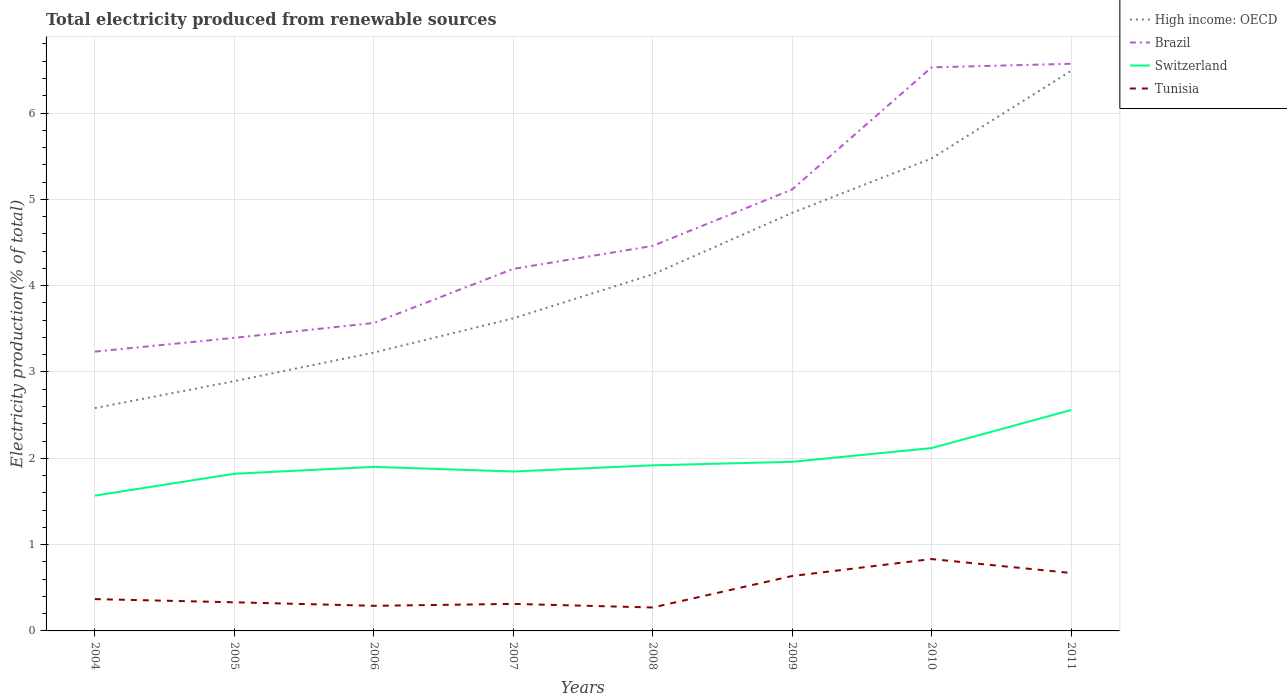How many different coloured lines are there?
Provide a short and direct response. 4. Does the line corresponding to Brazil intersect with the line corresponding to Switzerland?
Offer a very short reply. No. Is the number of lines equal to the number of legend labels?
Provide a succinct answer. Yes. Across all years, what is the maximum total electricity produced in Brazil?
Make the answer very short. 3.24. What is the total total electricity produced in Switzerland in the graph?
Your response must be concise. -0.99. What is the difference between the highest and the second highest total electricity produced in Brazil?
Offer a terse response. 3.33. Is the total electricity produced in High income: OECD strictly greater than the total electricity produced in Brazil over the years?
Provide a short and direct response. Yes. How many lines are there?
Give a very brief answer. 4. How many years are there in the graph?
Provide a short and direct response. 8. What is the difference between two consecutive major ticks on the Y-axis?
Your answer should be compact. 1. Are the values on the major ticks of Y-axis written in scientific E-notation?
Provide a short and direct response. No. Does the graph contain any zero values?
Offer a terse response. No. Does the graph contain grids?
Make the answer very short. Yes. What is the title of the graph?
Your answer should be very brief. Total electricity produced from renewable sources. What is the label or title of the X-axis?
Keep it short and to the point. Years. What is the Electricity production(% of total) in High income: OECD in 2004?
Keep it short and to the point. 2.58. What is the Electricity production(% of total) in Brazil in 2004?
Provide a short and direct response. 3.24. What is the Electricity production(% of total) in Switzerland in 2004?
Your response must be concise. 1.57. What is the Electricity production(% of total) in Tunisia in 2004?
Give a very brief answer. 0.37. What is the Electricity production(% of total) in High income: OECD in 2005?
Your answer should be compact. 2.89. What is the Electricity production(% of total) in Brazil in 2005?
Your response must be concise. 3.4. What is the Electricity production(% of total) in Switzerland in 2005?
Your response must be concise. 1.82. What is the Electricity production(% of total) of Tunisia in 2005?
Offer a terse response. 0.33. What is the Electricity production(% of total) in High income: OECD in 2006?
Your answer should be compact. 3.22. What is the Electricity production(% of total) of Brazil in 2006?
Give a very brief answer. 3.57. What is the Electricity production(% of total) of Switzerland in 2006?
Provide a short and direct response. 1.9. What is the Electricity production(% of total) in Tunisia in 2006?
Your answer should be compact. 0.29. What is the Electricity production(% of total) of High income: OECD in 2007?
Your response must be concise. 3.62. What is the Electricity production(% of total) of Brazil in 2007?
Offer a very short reply. 4.19. What is the Electricity production(% of total) of Switzerland in 2007?
Give a very brief answer. 1.85. What is the Electricity production(% of total) of Tunisia in 2007?
Make the answer very short. 0.31. What is the Electricity production(% of total) in High income: OECD in 2008?
Give a very brief answer. 4.13. What is the Electricity production(% of total) in Brazil in 2008?
Provide a succinct answer. 4.46. What is the Electricity production(% of total) of Switzerland in 2008?
Your response must be concise. 1.92. What is the Electricity production(% of total) of Tunisia in 2008?
Make the answer very short. 0.27. What is the Electricity production(% of total) in High income: OECD in 2009?
Your answer should be compact. 4.84. What is the Electricity production(% of total) of Brazil in 2009?
Your response must be concise. 5.11. What is the Electricity production(% of total) of Switzerland in 2009?
Make the answer very short. 1.96. What is the Electricity production(% of total) of Tunisia in 2009?
Provide a short and direct response. 0.64. What is the Electricity production(% of total) in High income: OECD in 2010?
Make the answer very short. 5.47. What is the Electricity production(% of total) in Brazil in 2010?
Make the answer very short. 6.53. What is the Electricity production(% of total) of Switzerland in 2010?
Offer a terse response. 2.12. What is the Electricity production(% of total) in Tunisia in 2010?
Ensure brevity in your answer.  0.83. What is the Electricity production(% of total) of High income: OECD in 2011?
Ensure brevity in your answer.  6.49. What is the Electricity production(% of total) of Brazil in 2011?
Provide a short and direct response. 6.57. What is the Electricity production(% of total) of Switzerland in 2011?
Give a very brief answer. 2.56. What is the Electricity production(% of total) of Tunisia in 2011?
Ensure brevity in your answer.  0.67. Across all years, what is the maximum Electricity production(% of total) in High income: OECD?
Offer a very short reply. 6.49. Across all years, what is the maximum Electricity production(% of total) in Brazil?
Provide a succinct answer. 6.57. Across all years, what is the maximum Electricity production(% of total) in Switzerland?
Make the answer very short. 2.56. Across all years, what is the maximum Electricity production(% of total) of Tunisia?
Your response must be concise. 0.83. Across all years, what is the minimum Electricity production(% of total) in High income: OECD?
Provide a succinct answer. 2.58. Across all years, what is the minimum Electricity production(% of total) in Brazil?
Ensure brevity in your answer.  3.24. Across all years, what is the minimum Electricity production(% of total) in Switzerland?
Your response must be concise. 1.57. Across all years, what is the minimum Electricity production(% of total) in Tunisia?
Provide a short and direct response. 0.27. What is the total Electricity production(% of total) in High income: OECD in the graph?
Ensure brevity in your answer.  33.26. What is the total Electricity production(% of total) in Brazil in the graph?
Your answer should be compact. 37.07. What is the total Electricity production(% of total) in Switzerland in the graph?
Keep it short and to the point. 15.69. What is the total Electricity production(% of total) in Tunisia in the graph?
Offer a terse response. 3.72. What is the difference between the Electricity production(% of total) in High income: OECD in 2004 and that in 2005?
Offer a very short reply. -0.31. What is the difference between the Electricity production(% of total) of Brazil in 2004 and that in 2005?
Provide a short and direct response. -0.16. What is the difference between the Electricity production(% of total) in Switzerland in 2004 and that in 2005?
Provide a succinct answer. -0.25. What is the difference between the Electricity production(% of total) in Tunisia in 2004 and that in 2005?
Offer a very short reply. 0.04. What is the difference between the Electricity production(% of total) in High income: OECD in 2004 and that in 2006?
Make the answer very short. -0.64. What is the difference between the Electricity production(% of total) in Brazil in 2004 and that in 2006?
Give a very brief answer. -0.33. What is the difference between the Electricity production(% of total) of Switzerland in 2004 and that in 2006?
Make the answer very short. -0.33. What is the difference between the Electricity production(% of total) in Tunisia in 2004 and that in 2006?
Your response must be concise. 0.08. What is the difference between the Electricity production(% of total) in High income: OECD in 2004 and that in 2007?
Make the answer very short. -1.04. What is the difference between the Electricity production(% of total) in Brazil in 2004 and that in 2007?
Offer a very short reply. -0.96. What is the difference between the Electricity production(% of total) of Switzerland in 2004 and that in 2007?
Offer a terse response. -0.28. What is the difference between the Electricity production(% of total) of Tunisia in 2004 and that in 2007?
Your response must be concise. 0.06. What is the difference between the Electricity production(% of total) in High income: OECD in 2004 and that in 2008?
Make the answer very short. -1.55. What is the difference between the Electricity production(% of total) of Brazil in 2004 and that in 2008?
Ensure brevity in your answer.  -1.22. What is the difference between the Electricity production(% of total) in Switzerland in 2004 and that in 2008?
Offer a very short reply. -0.35. What is the difference between the Electricity production(% of total) in Tunisia in 2004 and that in 2008?
Your response must be concise. 0.1. What is the difference between the Electricity production(% of total) of High income: OECD in 2004 and that in 2009?
Offer a terse response. -2.26. What is the difference between the Electricity production(% of total) in Brazil in 2004 and that in 2009?
Offer a terse response. -1.88. What is the difference between the Electricity production(% of total) in Switzerland in 2004 and that in 2009?
Give a very brief answer. -0.39. What is the difference between the Electricity production(% of total) of Tunisia in 2004 and that in 2009?
Ensure brevity in your answer.  -0.27. What is the difference between the Electricity production(% of total) of High income: OECD in 2004 and that in 2010?
Keep it short and to the point. -2.89. What is the difference between the Electricity production(% of total) of Brazil in 2004 and that in 2010?
Offer a very short reply. -3.29. What is the difference between the Electricity production(% of total) in Switzerland in 2004 and that in 2010?
Give a very brief answer. -0.55. What is the difference between the Electricity production(% of total) of Tunisia in 2004 and that in 2010?
Your answer should be very brief. -0.46. What is the difference between the Electricity production(% of total) in High income: OECD in 2004 and that in 2011?
Your response must be concise. -3.91. What is the difference between the Electricity production(% of total) of Brazil in 2004 and that in 2011?
Make the answer very short. -3.33. What is the difference between the Electricity production(% of total) in Switzerland in 2004 and that in 2011?
Offer a very short reply. -0.99. What is the difference between the Electricity production(% of total) of Tunisia in 2004 and that in 2011?
Give a very brief answer. -0.3. What is the difference between the Electricity production(% of total) of High income: OECD in 2005 and that in 2006?
Make the answer very short. -0.33. What is the difference between the Electricity production(% of total) of Brazil in 2005 and that in 2006?
Your response must be concise. -0.17. What is the difference between the Electricity production(% of total) of Switzerland in 2005 and that in 2006?
Ensure brevity in your answer.  -0.08. What is the difference between the Electricity production(% of total) in Tunisia in 2005 and that in 2006?
Provide a short and direct response. 0.04. What is the difference between the Electricity production(% of total) in High income: OECD in 2005 and that in 2007?
Provide a short and direct response. -0.73. What is the difference between the Electricity production(% of total) in Brazil in 2005 and that in 2007?
Provide a succinct answer. -0.8. What is the difference between the Electricity production(% of total) in Switzerland in 2005 and that in 2007?
Ensure brevity in your answer.  -0.03. What is the difference between the Electricity production(% of total) of Tunisia in 2005 and that in 2007?
Give a very brief answer. 0.02. What is the difference between the Electricity production(% of total) in High income: OECD in 2005 and that in 2008?
Offer a terse response. -1.24. What is the difference between the Electricity production(% of total) in Brazil in 2005 and that in 2008?
Your answer should be compact. -1.06. What is the difference between the Electricity production(% of total) of Switzerland in 2005 and that in 2008?
Provide a short and direct response. -0.1. What is the difference between the Electricity production(% of total) in Tunisia in 2005 and that in 2008?
Keep it short and to the point. 0.06. What is the difference between the Electricity production(% of total) of High income: OECD in 2005 and that in 2009?
Provide a short and direct response. -1.95. What is the difference between the Electricity production(% of total) of Brazil in 2005 and that in 2009?
Make the answer very short. -1.72. What is the difference between the Electricity production(% of total) of Switzerland in 2005 and that in 2009?
Provide a short and direct response. -0.14. What is the difference between the Electricity production(% of total) of Tunisia in 2005 and that in 2009?
Your response must be concise. -0.3. What is the difference between the Electricity production(% of total) of High income: OECD in 2005 and that in 2010?
Provide a short and direct response. -2.58. What is the difference between the Electricity production(% of total) in Brazil in 2005 and that in 2010?
Ensure brevity in your answer.  -3.13. What is the difference between the Electricity production(% of total) in Switzerland in 2005 and that in 2010?
Offer a very short reply. -0.3. What is the difference between the Electricity production(% of total) in Tunisia in 2005 and that in 2010?
Your answer should be compact. -0.5. What is the difference between the Electricity production(% of total) of High income: OECD in 2005 and that in 2011?
Make the answer very short. -3.6. What is the difference between the Electricity production(% of total) of Brazil in 2005 and that in 2011?
Your answer should be compact. -3.18. What is the difference between the Electricity production(% of total) in Switzerland in 2005 and that in 2011?
Offer a very short reply. -0.74. What is the difference between the Electricity production(% of total) of Tunisia in 2005 and that in 2011?
Provide a short and direct response. -0.34. What is the difference between the Electricity production(% of total) of High income: OECD in 2006 and that in 2007?
Give a very brief answer. -0.4. What is the difference between the Electricity production(% of total) in Brazil in 2006 and that in 2007?
Offer a very short reply. -0.63. What is the difference between the Electricity production(% of total) in Switzerland in 2006 and that in 2007?
Ensure brevity in your answer.  0.05. What is the difference between the Electricity production(% of total) of Tunisia in 2006 and that in 2007?
Provide a succinct answer. -0.02. What is the difference between the Electricity production(% of total) of High income: OECD in 2006 and that in 2008?
Give a very brief answer. -0.91. What is the difference between the Electricity production(% of total) of Brazil in 2006 and that in 2008?
Ensure brevity in your answer.  -0.89. What is the difference between the Electricity production(% of total) of Switzerland in 2006 and that in 2008?
Your response must be concise. -0.02. What is the difference between the Electricity production(% of total) in Tunisia in 2006 and that in 2008?
Offer a terse response. 0.02. What is the difference between the Electricity production(% of total) in High income: OECD in 2006 and that in 2009?
Your answer should be compact. -1.62. What is the difference between the Electricity production(% of total) in Brazil in 2006 and that in 2009?
Ensure brevity in your answer.  -1.55. What is the difference between the Electricity production(% of total) of Switzerland in 2006 and that in 2009?
Offer a very short reply. -0.06. What is the difference between the Electricity production(% of total) in Tunisia in 2006 and that in 2009?
Offer a very short reply. -0.34. What is the difference between the Electricity production(% of total) of High income: OECD in 2006 and that in 2010?
Your answer should be compact. -2.25. What is the difference between the Electricity production(% of total) in Brazil in 2006 and that in 2010?
Your response must be concise. -2.96. What is the difference between the Electricity production(% of total) of Switzerland in 2006 and that in 2010?
Your answer should be very brief. -0.22. What is the difference between the Electricity production(% of total) of Tunisia in 2006 and that in 2010?
Your response must be concise. -0.54. What is the difference between the Electricity production(% of total) in High income: OECD in 2006 and that in 2011?
Your answer should be compact. -3.26. What is the difference between the Electricity production(% of total) of Brazil in 2006 and that in 2011?
Your answer should be very brief. -3. What is the difference between the Electricity production(% of total) of Switzerland in 2006 and that in 2011?
Your answer should be compact. -0.66. What is the difference between the Electricity production(% of total) of Tunisia in 2006 and that in 2011?
Make the answer very short. -0.38. What is the difference between the Electricity production(% of total) of High income: OECD in 2007 and that in 2008?
Make the answer very short. -0.51. What is the difference between the Electricity production(% of total) in Brazil in 2007 and that in 2008?
Provide a short and direct response. -0.27. What is the difference between the Electricity production(% of total) of Switzerland in 2007 and that in 2008?
Your response must be concise. -0.07. What is the difference between the Electricity production(% of total) of Tunisia in 2007 and that in 2008?
Make the answer very short. 0.04. What is the difference between the Electricity production(% of total) in High income: OECD in 2007 and that in 2009?
Give a very brief answer. -1.22. What is the difference between the Electricity production(% of total) in Brazil in 2007 and that in 2009?
Your answer should be compact. -0.92. What is the difference between the Electricity production(% of total) of Switzerland in 2007 and that in 2009?
Your response must be concise. -0.11. What is the difference between the Electricity production(% of total) in Tunisia in 2007 and that in 2009?
Offer a terse response. -0.32. What is the difference between the Electricity production(% of total) of High income: OECD in 2007 and that in 2010?
Keep it short and to the point. -1.85. What is the difference between the Electricity production(% of total) in Brazil in 2007 and that in 2010?
Offer a very short reply. -2.33. What is the difference between the Electricity production(% of total) of Switzerland in 2007 and that in 2010?
Your answer should be compact. -0.27. What is the difference between the Electricity production(% of total) of Tunisia in 2007 and that in 2010?
Provide a short and direct response. -0.52. What is the difference between the Electricity production(% of total) in High income: OECD in 2007 and that in 2011?
Provide a succinct answer. -2.87. What is the difference between the Electricity production(% of total) of Brazil in 2007 and that in 2011?
Provide a succinct answer. -2.38. What is the difference between the Electricity production(% of total) of Switzerland in 2007 and that in 2011?
Provide a succinct answer. -0.71. What is the difference between the Electricity production(% of total) in Tunisia in 2007 and that in 2011?
Keep it short and to the point. -0.36. What is the difference between the Electricity production(% of total) of High income: OECD in 2008 and that in 2009?
Provide a short and direct response. -0.71. What is the difference between the Electricity production(% of total) of Brazil in 2008 and that in 2009?
Make the answer very short. -0.65. What is the difference between the Electricity production(% of total) of Switzerland in 2008 and that in 2009?
Provide a succinct answer. -0.04. What is the difference between the Electricity production(% of total) in Tunisia in 2008 and that in 2009?
Offer a very short reply. -0.36. What is the difference between the Electricity production(% of total) in High income: OECD in 2008 and that in 2010?
Offer a very short reply. -1.34. What is the difference between the Electricity production(% of total) in Brazil in 2008 and that in 2010?
Give a very brief answer. -2.07. What is the difference between the Electricity production(% of total) of Switzerland in 2008 and that in 2010?
Your answer should be very brief. -0.2. What is the difference between the Electricity production(% of total) of Tunisia in 2008 and that in 2010?
Your answer should be very brief. -0.56. What is the difference between the Electricity production(% of total) of High income: OECD in 2008 and that in 2011?
Offer a terse response. -2.36. What is the difference between the Electricity production(% of total) of Brazil in 2008 and that in 2011?
Provide a succinct answer. -2.11. What is the difference between the Electricity production(% of total) of Switzerland in 2008 and that in 2011?
Offer a very short reply. -0.64. What is the difference between the Electricity production(% of total) in Tunisia in 2008 and that in 2011?
Provide a short and direct response. -0.4. What is the difference between the Electricity production(% of total) in High income: OECD in 2009 and that in 2010?
Your answer should be very brief. -0.63. What is the difference between the Electricity production(% of total) in Brazil in 2009 and that in 2010?
Your answer should be very brief. -1.41. What is the difference between the Electricity production(% of total) in Switzerland in 2009 and that in 2010?
Your response must be concise. -0.16. What is the difference between the Electricity production(% of total) in Tunisia in 2009 and that in 2010?
Provide a succinct answer. -0.2. What is the difference between the Electricity production(% of total) in High income: OECD in 2009 and that in 2011?
Offer a very short reply. -1.65. What is the difference between the Electricity production(% of total) in Brazil in 2009 and that in 2011?
Offer a terse response. -1.46. What is the difference between the Electricity production(% of total) of Switzerland in 2009 and that in 2011?
Ensure brevity in your answer.  -0.6. What is the difference between the Electricity production(% of total) in Tunisia in 2009 and that in 2011?
Your response must be concise. -0.04. What is the difference between the Electricity production(% of total) of High income: OECD in 2010 and that in 2011?
Your answer should be compact. -1.01. What is the difference between the Electricity production(% of total) in Brazil in 2010 and that in 2011?
Keep it short and to the point. -0.04. What is the difference between the Electricity production(% of total) in Switzerland in 2010 and that in 2011?
Your response must be concise. -0.44. What is the difference between the Electricity production(% of total) of Tunisia in 2010 and that in 2011?
Offer a terse response. 0.16. What is the difference between the Electricity production(% of total) of High income: OECD in 2004 and the Electricity production(% of total) of Brazil in 2005?
Ensure brevity in your answer.  -0.81. What is the difference between the Electricity production(% of total) in High income: OECD in 2004 and the Electricity production(% of total) in Switzerland in 2005?
Provide a succinct answer. 0.76. What is the difference between the Electricity production(% of total) of High income: OECD in 2004 and the Electricity production(% of total) of Tunisia in 2005?
Provide a short and direct response. 2.25. What is the difference between the Electricity production(% of total) in Brazil in 2004 and the Electricity production(% of total) in Switzerland in 2005?
Make the answer very short. 1.42. What is the difference between the Electricity production(% of total) of Brazil in 2004 and the Electricity production(% of total) of Tunisia in 2005?
Offer a very short reply. 2.9. What is the difference between the Electricity production(% of total) in Switzerland in 2004 and the Electricity production(% of total) in Tunisia in 2005?
Offer a terse response. 1.24. What is the difference between the Electricity production(% of total) in High income: OECD in 2004 and the Electricity production(% of total) in Brazil in 2006?
Your response must be concise. -0.99. What is the difference between the Electricity production(% of total) of High income: OECD in 2004 and the Electricity production(% of total) of Switzerland in 2006?
Offer a very short reply. 0.68. What is the difference between the Electricity production(% of total) in High income: OECD in 2004 and the Electricity production(% of total) in Tunisia in 2006?
Offer a very short reply. 2.29. What is the difference between the Electricity production(% of total) of Brazil in 2004 and the Electricity production(% of total) of Switzerland in 2006?
Offer a terse response. 1.33. What is the difference between the Electricity production(% of total) of Brazil in 2004 and the Electricity production(% of total) of Tunisia in 2006?
Your response must be concise. 2.94. What is the difference between the Electricity production(% of total) of Switzerland in 2004 and the Electricity production(% of total) of Tunisia in 2006?
Make the answer very short. 1.28. What is the difference between the Electricity production(% of total) in High income: OECD in 2004 and the Electricity production(% of total) in Brazil in 2007?
Your answer should be very brief. -1.61. What is the difference between the Electricity production(% of total) of High income: OECD in 2004 and the Electricity production(% of total) of Switzerland in 2007?
Your response must be concise. 0.73. What is the difference between the Electricity production(% of total) in High income: OECD in 2004 and the Electricity production(% of total) in Tunisia in 2007?
Your answer should be compact. 2.27. What is the difference between the Electricity production(% of total) of Brazil in 2004 and the Electricity production(% of total) of Switzerland in 2007?
Give a very brief answer. 1.39. What is the difference between the Electricity production(% of total) in Brazil in 2004 and the Electricity production(% of total) in Tunisia in 2007?
Your answer should be very brief. 2.92. What is the difference between the Electricity production(% of total) of Switzerland in 2004 and the Electricity production(% of total) of Tunisia in 2007?
Provide a succinct answer. 1.25. What is the difference between the Electricity production(% of total) in High income: OECD in 2004 and the Electricity production(% of total) in Brazil in 2008?
Make the answer very short. -1.88. What is the difference between the Electricity production(% of total) of High income: OECD in 2004 and the Electricity production(% of total) of Switzerland in 2008?
Give a very brief answer. 0.66. What is the difference between the Electricity production(% of total) of High income: OECD in 2004 and the Electricity production(% of total) of Tunisia in 2008?
Offer a terse response. 2.31. What is the difference between the Electricity production(% of total) in Brazil in 2004 and the Electricity production(% of total) in Switzerland in 2008?
Provide a succinct answer. 1.32. What is the difference between the Electricity production(% of total) in Brazil in 2004 and the Electricity production(% of total) in Tunisia in 2008?
Your answer should be very brief. 2.96. What is the difference between the Electricity production(% of total) in Switzerland in 2004 and the Electricity production(% of total) in Tunisia in 2008?
Offer a very short reply. 1.3. What is the difference between the Electricity production(% of total) in High income: OECD in 2004 and the Electricity production(% of total) in Brazil in 2009?
Ensure brevity in your answer.  -2.53. What is the difference between the Electricity production(% of total) of High income: OECD in 2004 and the Electricity production(% of total) of Switzerland in 2009?
Provide a short and direct response. 0.62. What is the difference between the Electricity production(% of total) of High income: OECD in 2004 and the Electricity production(% of total) of Tunisia in 2009?
Offer a terse response. 1.95. What is the difference between the Electricity production(% of total) in Brazil in 2004 and the Electricity production(% of total) in Switzerland in 2009?
Ensure brevity in your answer.  1.28. What is the difference between the Electricity production(% of total) of Brazil in 2004 and the Electricity production(% of total) of Tunisia in 2009?
Offer a terse response. 2.6. What is the difference between the Electricity production(% of total) in Switzerland in 2004 and the Electricity production(% of total) in Tunisia in 2009?
Ensure brevity in your answer.  0.93. What is the difference between the Electricity production(% of total) of High income: OECD in 2004 and the Electricity production(% of total) of Brazil in 2010?
Keep it short and to the point. -3.95. What is the difference between the Electricity production(% of total) in High income: OECD in 2004 and the Electricity production(% of total) in Switzerland in 2010?
Offer a very short reply. 0.46. What is the difference between the Electricity production(% of total) in High income: OECD in 2004 and the Electricity production(% of total) in Tunisia in 2010?
Make the answer very short. 1.75. What is the difference between the Electricity production(% of total) of Brazil in 2004 and the Electricity production(% of total) of Switzerland in 2010?
Your answer should be very brief. 1.12. What is the difference between the Electricity production(% of total) of Brazil in 2004 and the Electricity production(% of total) of Tunisia in 2010?
Provide a short and direct response. 2.4. What is the difference between the Electricity production(% of total) of Switzerland in 2004 and the Electricity production(% of total) of Tunisia in 2010?
Your answer should be very brief. 0.73. What is the difference between the Electricity production(% of total) in High income: OECD in 2004 and the Electricity production(% of total) in Brazil in 2011?
Ensure brevity in your answer.  -3.99. What is the difference between the Electricity production(% of total) in High income: OECD in 2004 and the Electricity production(% of total) in Switzerland in 2011?
Provide a succinct answer. 0.02. What is the difference between the Electricity production(% of total) in High income: OECD in 2004 and the Electricity production(% of total) in Tunisia in 2011?
Your answer should be very brief. 1.91. What is the difference between the Electricity production(% of total) in Brazil in 2004 and the Electricity production(% of total) in Switzerland in 2011?
Your answer should be very brief. 0.68. What is the difference between the Electricity production(% of total) in Brazil in 2004 and the Electricity production(% of total) in Tunisia in 2011?
Your answer should be compact. 2.56. What is the difference between the Electricity production(% of total) of Switzerland in 2004 and the Electricity production(% of total) of Tunisia in 2011?
Offer a terse response. 0.9. What is the difference between the Electricity production(% of total) in High income: OECD in 2005 and the Electricity production(% of total) in Brazil in 2006?
Your answer should be compact. -0.67. What is the difference between the Electricity production(% of total) of High income: OECD in 2005 and the Electricity production(% of total) of Switzerland in 2006?
Your response must be concise. 0.99. What is the difference between the Electricity production(% of total) of High income: OECD in 2005 and the Electricity production(% of total) of Tunisia in 2006?
Keep it short and to the point. 2.6. What is the difference between the Electricity production(% of total) in Brazil in 2005 and the Electricity production(% of total) in Switzerland in 2006?
Ensure brevity in your answer.  1.49. What is the difference between the Electricity production(% of total) of Brazil in 2005 and the Electricity production(% of total) of Tunisia in 2006?
Keep it short and to the point. 3.1. What is the difference between the Electricity production(% of total) of Switzerland in 2005 and the Electricity production(% of total) of Tunisia in 2006?
Provide a succinct answer. 1.53. What is the difference between the Electricity production(% of total) of High income: OECD in 2005 and the Electricity production(% of total) of Brazil in 2007?
Offer a terse response. -1.3. What is the difference between the Electricity production(% of total) in High income: OECD in 2005 and the Electricity production(% of total) in Switzerland in 2007?
Your response must be concise. 1.05. What is the difference between the Electricity production(% of total) in High income: OECD in 2005 and the Electricity production(% of total) in Tunisia in 2007?
Provide a succinct answer. 2.58. What is the difference between the Electricity production(% of total) of Brazil in 2005 and the Electricity production(% of total) of Switzerland in 2007?
Provide a short and direct response. 1.55. What is the difference between the Electricity production(% of total) in Brazil in 2005 and the Electricity production(% of total) in Tunisia in 2007?
Ensure brevity in your answer.  3.08. What is the difference between the Electricity production(% of total) of Switzerland in 2005 and the Electricity production(% of total) of Tunisia in 2007?
Offer a very short reply. 1.51. What is the difference between the Electricity production(% of total) of High income: OECD in 2005 and the Electricity production(% of total) of Brazil in 2008?
Give a very brief answer. -1.57. What is the difference between the Electricity production(% of total) of High income: OECD in 2005 and the Electricity production(% of total) of Switzerland in 2008?
Make the answer very short. 0.97. What is the difference between the Electricity production(% of total) in High income: OECD in 2005 and the Electricity production(% of total) in Tunisia in 2008?
Keep it short and to the point. 2.62. What is the difference between the Electricity production(% of total) in Brazil in 2005 and the Electricity production(% of total) in Switzerland in 2008?
Your response must be concise. 1.48. What is the difference between the Electricity production(% of total) of Brazil in 2005 and the Electricity production(% of total) of Tunisia in 2008?
Give a very brief answer. 3.12. What is the difference between the Electricity production(% of total) of Switzerland in 2005 and the Electricity production(% of total) of Tunisia in 2008?
Your answer should be very brief. 1.55. What is the difference between the Electricity production(% of total) in High income: OECD in 2005 and the Electricity production(% of total) in Brazil in 2009?
Keep it short and to the point. -2.22. What is the difference between the Electricity production(% of total) of High income: OECD in 2005 and the Electricity production(% of total) of Switzerland in 2009?
Offer a terse response. 0.93. What is the difference between the Electricity production(% of total) of High income: OECD in 2005 and the Electricity production(% of total) of Tunisia in 2009?
Offer a very short reply. 2.26. What is the difference between the Electricity production(% of total) in Brazil in 2005 and the Electricity production(% of total) in Switzerland in 2009?
Your answer should be very brief. 1.44. What is the difference between the Electricity production(% of total) in Brazil in 2005 and the Electricity production(% of total) in Tunisia in 2009?
Your response must be concise. 2.76. What is the difference between the Electricity production(% of total) of Switzerland in 2005 and the Electricity production(% of total) of Tunisia in 2009?
Give a very brief answer. 1.18. What is the difference between the Electricity production(% of total) of High income: OECD in 2005 and the Electricity production(% of total) of Brazil in 2010?
Provide a succinct answer. -3.64. What is the difference between the Electricity production(% of total) in High income: OECD in 2005 and the Electricity production(% of total) in Switzerland in 2010?
Give a very brief answer. 0.78. What is the difference between the Electricity production(% of total) of High income: OECD in 2005 and the Electricity production(% of total) of Tunisia in 2010?
Your response must be concise. 2.06. What is the difference between the Electricity production(% of total) in Brazil in 2005 and the Electricity production(% of total) in Switzerland in 2010?
Your response must be concise. 1.28. What is the difference between the Electricity production(% of total) of Brazil in 2005 and the Electricity production(% of total) of Tunisia in 2010?
Your answer should be compact. 2.56. What is the difference between the Electricity production(% of total) of Switzerland in 2005 and the Electricity production(% of total) of Tunisia in 2010?
Offer a terse response. 0.99. What is the difference between the Electricity production(% of total) in High income: OECD in 2005 and the Electricity production(% of total) in Brazil in 2011?
Your response must be concise. -3.68. What is the difference between the Electricity production(% of total) of High income: OECD in 2005 and the Electricity production(% of total) of Switzerland in 2011?
Provide a short and direct response. 0.33. What is the difference between the Electricity production(% of total) of High income: OECD in 2005 and the Electricity production(% of total) of Tunisia in 2011?
Offer a very short reply. 2.22. What is the difference between the Electricity production(% of total) in Brazil in 2005 and the Electricity production(% of total) in Switzerland in 2011?
Ensure brevity in your answer.  0.84. What is the difference between the Electricity production(% of total) of Brazil in 2005 and the Electricity production(% of total) of Tunisia in 2011?
Your answer should be compact. 2.72. What is the difference between the Electricity production(% of total) in Switzerland in 2005 and the Electricity production(% of total) in Tunisia in 2011?
Provide a succinct answer. 1.15. What is the difference between the Electricity production(% of total) of High income: OECD in 2006 and the Electricity production(% of total) of Brazil in 2007?
Offer a terse response. -0.97. What is the difference between the Electricity production(% of total) in High income: OECD in 2006 and the Electricity production(% of total) in Switzerland in 2007?
Ensure brevity in your answer.  1.38. What is the difference between the Electricity production(% of total) in High income: OECD in 2006 and the Electricity production(% of total) in Tunisia in 2007?
Offer a very short reply. 2.91. What is the difference between the Electricity production(% of total) of Brazil in 2006 and the Electricity production(% of total) of Switzerland in 2007?
Your answer should be compact. 1.72. What is the difference between the Electricity production(% of total) in Brazil in 2006 and the Electricity production(% of total) in Tunisia in 2007?
Make the answer very short. 3.25. What is the difference between the Electricity production(% of total) in Switzerland in 2006 and the Electricity production(% of total) in Tunisia in 2007?
Offer a very short reply. 1.59. What is the difference between the Electricity production(% of total) in High income: OECD in 2006 and the Electricity production(% of total) in Brazil in 2008?
Your answer should be very brief. -1.24. What is the difference between the Electricity production(% of total) in High income: OECD in 2006 and the Electricity production(% of total) in Switzerland in 2008?
Offer a terse response. 1.31. What is the difference between the Electricity production(% of total) of High income: OECD in 2006 and the Electricity production(% of total) of Tunisia in 2008?
Give a very brief answer. 2.95. What is the difference between the Electricity production(% of total) in Brazil in 2006 and the Electricity production(% of total) in Switzerland in 2008?
Your response must be concise. 1.65. What is the difference between the Electricity production(% of total) in Brazil in 2006 and the Electricity production(% of total) in Tunisia in 2008?
Provide a succinct answer. 3.3. What is the difference between the Electricity production(% of total) of Switzerland in 2006 and the Electricity production(% of total) of Tunisia in 2008?
Ensure brevity in your answer.  1.63. What is the difference between the Electricity production(% of total) in High income: OECD in 2006 and the Electricity production(% of total) in Brazil in 2009?
Offer a terse response. -1.89. What is the difference between the Electricity production(% of total) in High income: OECD in 2006 and the Electricity production(% of total) in Switzerland in 2009?
Offer a very short reply. 1.27. What is the difference between the Electricity production(% of total) of High income: OECD in 2006 and the Electricity production(% of total) of Tunisia in 2009?
Offer a very short reply. 2.59. What is the difference between the Electricity production(% of total) of Brazil in 2006 and the Electricity production(% of total) of Switzerland in 2009?
Provide a short and direct response. 1.61. What is the difference between the Electricity production(% of total) of Brazil in 2006 and the Electricity production(% of total) of Tunisia in 2009?
Make the answer very short. 2.93. What is the difference between the Electricity production(% of total) of Switzerland in 2006 and the Electricity production(% of total) of Tunisia in 2009?
Provide a short and direct response. 1.26. What is the difference between the Electricity production(% of total) in High income: OECD in 2006 and the Electricity production(% of total) in Brazil in 2010?
Your answer should be compact. -3.3. What is the difference between the Electricity production(% of total) in High income: OECD in 2006 and the Electricity production(% of total) in Switzerland in 2010?
Your answer should be compact. 1.11. What is the difference between the Electricity production(% of total) of High income: OECD in 2006 and the Electricity production(% of total) of Tunisia in 2010?
Make the answer very short. 2.39. What is the difference between the Electricity production(% of total) of Brazil in 2006 and the Electricity production(% of total) of Switzerland in 2010?
Make the answer very short. 1.45. What is the difference between the Electricity production(% of total) in Brazil in 2006 and the Electricity production(% of total) in Tunisia in 2010?
Make the answer very short. 2.73. What is the difference between the Electricity production(% of total) in Switzerland in 2006 and the Electricity production(% of total) in Tunisia in 2010?
Offer a terse response. 1.07. What is the difference between the Electricity production(% of total) of High income: OECD in 2006 and the Electricity production(% of total) of Brazil in 2011?
Offer a terse response. -3.35. What is the difference between the Electricity production(% of total) of High income: OECD in 2006 and the Electricity production(% of total) of Switzerland in 2011?
Give a very brief answer. 0.67. What is the difference between the Electricity production(% of total) of High income: OECD in 2006 and the Electricity production(% of total) of Tunisia in 2011?
Keep it short and to the point. 2.55. What is the difference between the Electricity production(% of total) of Brazil in 2006 and the Electricity production(% of total) of Switzerland in 2011?
Make the answer very short. 1.01. What is the difference between the Electricity production(% of total) of Brazil in 2006 and the Electricity production(% of total) of Tunisia in 2011?
Offer a terse response. 2.9. What is the difference between the Electricity production(% of total) of Switzerland in 2006 and the Electricity production(% of total) of Tunisia in 2011?
Provide a succinct answer. 1.23. What is the difference between the Electricity production(% of total) in High income: OECD in 2007 and the Electricity production(% of total) in Brazil in 2008?
Keep it short and to the point. -0.84. What is the difference between the Electricity production(% of total) of High income: OECD in 2007 and the Electricity production(% of total) of Switzerland in 2008?
Provide a succinct answer. 1.7. What is the difference between the Electricity production(% of total) in High income: OECD in 2007 and the Electricity production(% of total) in Tunisia in 2008?
Offer a very short reply. 3.35. What is the difference between the Electricity production(% of total) in Brazil in 2007 and the Electricity production(% of total) in Switzerland in 2008?
Your answer should be compact. 2.28. What is the difference between the Electricity production(% of total) in Brazil in 2007 and the Electricity production(% of total) in Tunisia in 2008?
Ensure brevity in your answer.  3.92. What is the difference between the Electricity production(% of total) in Switzerland in 2007 and the Electricity production(% of total) in Tunisia in 2008?
Ensure brevity in your answer.  1.58. What is the difference between the Electricity production(% of total) in High income: OECD in 2007 and the Electricity production(% of total) in Brazil in 2009?
Give a very brief answer. -1.49. What is the difference between the Electricity production(% of total) of High income: OECD in 2007 and the Electricity production(% of total) of Switzerland in 2009?
Provide a succinct answer. 1.66. What is the difference between the Electricity production(% of total) of High income: OECD in 2007 and the Electricity production(% of total) of Tunisia in 2009?
Offer a terse response. 2.98. What is the difference between the Electricity production(% of total) of Brazil in 2007 and the Electricity production(% of total) of Switzerland in 2009?
Give a very brief answer. 2.24. What is the difference between the Electricity production(% of total) in Brazil in 2007 and the Electricity production(% of total) in Tunisia in 2009?
Your answer should be compact. 3.56. What is the difference between the Electricity production(% of total) in Switzerland in 2007 and the Electricity production(% of total) in Tunisia in 2009?
Offer a very short reply. 1.21. What is the difference between the Electricity production(% of total) of High income: OECD in 2007 and the Electricity production(% of total) of Brazil in 2010?
Offer a very short reply. -2.91. What is the difference between the Electricity production(% of total) in High income: OECD in 2007 and the Electricity production(% of total) in Switzerland in 2010?
Offer a very short reply. 1.5. What is the difference between the Electricity production(% of total) in High income: OECD in 2007 and the Electricity production(% of total) in Tunisia in 2010?
Keep it short and to the point. 2.79. What is the difference between the Electricity production(% of total) of Brazil in 2007 and the Electricity production(% of total) of Switzerland in 2010?
Your answer should be very brief. 2.08. What is the difference between the Electricity production(% of total) in Brazil in 2007 and the Electricity production(% of total) in Tunisia in 2010?
Provide a succinct answer. 3.36. What is the difference between the Electricity production(% of total) of Switzerland in 2007 and the Electricity production(% of total) of Tunisia in 2010?
Your answer should be compact. 1.01. What is the difference between the Electricity production(% of total) of High income: OECD in 2007 and the Electricity production(% of total) of Brazil in 2011?
Your answer should be compact. -2.95. What is the difference between the Electricity production(% of total) of High income: OECD in 2007 and the Electricity production(% of total) of Switzerland in 2011?
Keep it short and to the point. 1.06. What is the difference between the Electricity production(% of total) of High income: OECD in 2007 and the Electricity production(% of total) of Tunisia in 2011?
Give a very brief answer. 2.95. What is the difference between the Electricity production(% of total) of Brazil in 2007 and the Electricity production(% of total) of Switzerland in 2011?
Give a very brief answer. 1.64. What is the difference between the Electricity production(% of total) in Brazil in 2007 and the Electricity production(% of total) in Tunisia in 2011?
Offer a terse response. 3.52. What is the difference between the Electricity production(% of total) of Switzerland in 2007 and the Electricity production(% of total) of Tunisia in 2011?
Make the answer very short. 1.18. What is the difference between the Electricity production(% of total) of High income: OECD in 2008 and the Electricity production(% of total) of Brazil in 2009?
Your answer should be very brief. -0.98. What is the difference between the Electricity production(% of total) in High income: OECD in 2008 and the Electricity production(% of total) in Switzerland in 2009?
Your answer should be very brief. 2.17. What is the difference between the Electricity production(% of total) of High income: OECD in 2008 and the Electricity production(% of total) of Tunisia in 2009?
Offer a terse response. 3.49. What is the difference between the Electricity production(% of total) in Brazil in 2008 and the Electricity production(% of total) in Switzerland in 2009?
Provide a succinct answer. 2.5. What is the difference between the Electricity production(% of total) in Brazil in 2008 and the Electricity production(% of total) in Tunisia in 2009?
Keep it short and to the point. 3.82. What is the difference between the Electricity production(% of total) of Switzerland in 2008 and the Electricity production(% of total) of Tunisia in 2009?
Offer a terse response. 1.28. What is the difference between the Electricity production(% of total) of High income: OECD in 2008 and the Electricity production(% of total) of Brazil in 2010?
Your response must be concise. -2.4. What is the difference between the Electricity production(% of total) in High income: OECD in 2008 and the Electricity production(% of total) in Switzerland in 2010?
Offer a very short reply. 2.01. What is the difference between the Electricity production(% of total) of High income: OECD in 2008 and the Electricity production(% of total) of Tunisia in 2010?
Provide a short and direct response. 3.3. What is the difference between the Electricity production(% of total) in Brazil in 2008 and the Electricity production(% of total) in Switzerland in 2010?
Give a very brief answer. 2.34. What is the difference between the Electricity production(% of total) of Brazil in 2008 and the Electricity production(% of total) of Tunisia in 2010?
Offer a terse response. 3.63. What is the difference between the Electricity production(% of total) of Switzerland in 2008 and the Electricity production(% of total) of Tunisia in 2010?
Your response must be concise. 1.09. What is the difference between the Electricity production(% of total) in High income: OECD in 2008 and the Electricity production(% of total) in Brazil in 2011?
Your answer should be very brief. -2.44. What is the difference between the Electricity production(% of total) of High income: OECD in 2008 and the Electricity production(% of total) of Switzerland in 2011?
Provide a short and direct response. 1.57. What is the difference between the Electricity production(% of total) in High income: OECD in 2008 and the Electricity production(% of total) in Tunisia in 2011?
Your response must be concise. 3.46. What is the difference between the Electricity production(% of total) of Brazil in 2008 and the Electricity production(% of total) of Switzerland in 2011?
Your response must be concise. 1.9. What is the difference between the Electricity production(% of total) in Brazil in 2008 and the Electricity production(% of total) in Tunisia in 2011?
Give a very brief answer. 3.79. What is the difference between the Electricity production(% of total) of Switzerland in 2008 and the Electricity production(% of total) of Tunisia in 2011?
Offer a very short reply. 1.25. What is the difference between the Electricity production(% of total) in High income: OECD in 2009 and the Electricity production(% of total) in Brazil in 2010?
Your answer should be compact. -1.69. What is the difference between the Electricity production(% of total) in High income: OECD in 2009 and the Electricity production(% of total) in Switzerland in 2010?
Your response must be concise. 2.73. What is the difference between the Electricity production(% of total) of High income: OECD in 2009 and the Electricity production(% of total) of Tunisia in 2010?
Offer a very short reply. 4.01. What is the difference between the Electricity production(% of total) of Brazil in 2009 and the Electricity production(% of total) of Switzerland in 2010?
Provide a succinct answer. 3. What is the difference between the Electricity production(% of total) in Brazil in 2009 and the Electricity production(% of total) in Tunisia in 2010?
Keep it short and to the point. 4.28. What is the difference between the Electricity production(% of total) in Switzerland in 2009 and the Electricity production(% of total) in Tunisia in 2010?
Offer a terse response. 1.13. What is the difference between the Electricity production(% of total) in High income: OECD in 2009 and the Electricity production(% of total) in Brazil in 2011?
Provide a succinct answer. -1.73. What is the difference between the Electricity production(% of total) in High income: OECD in 2009 and the Electricity production(% of total) in Switzerland in 2011?
Ensure brevity in your answer.  2.28. What is the difference between the Electricity production(% of total) in High income: OECD in 2009 and the Electricity production(% of total) in Tunisia in 2011?
Offer a very short reply. 4.17. What is the difference between the Electricity production(% of total) in Brazil in 2009 and the Electricity production(% of total) in Switzerland in 2011?
Your answer should be very brief. 2.56. What is the difference between the Electricity production(% of total) in Brazil in 2009 and the Electricity production(% of total) in Tunisia in 2011?
Offer a very short reply. 4.44. What is the difference between the Electricity production(% of total) in Switzerland in 2009 and the Electricity production(% of total) in Tunisia in 2011?
Offer a terse response. 1.29. What is the difference between the Electricity production(% of total) of High income: OECD in 2010 and the Electricity production(% of total) of Brazil in 2011?
Provide a succinct answer. -1.1. What is the difference between the Electricity production(% of total) of High income: OECD in 2010 and the Electricity production(% of total) of Switzerland in 2011?
Give a very brief answer. 2.91. What is the difference between the Electricity production(% of total) in High income: OECD in 2010 and the Electricity production(% of total) in Tunisia in 2011?
Provide a short and direct response. 4.8. What is the difference between the Electricity production(% of total) of Brazil in 2010 and the Electricity production(% of total) of Switzerland in 2011?
Offer a very short reply. 3.97. What is the difference between the Electricity production(% of total) of Brazil in 2010 and the Electricity production(% of total) of Tunisia in 2011?
Offer a very short reply. 5.86. What is the difference between the Electricity production(% of total) of Switzerland in 2010 and the Electricity production(% of total) of Tunisia in 2011?
Ensure brevity in your answer.  1.45. What is the average Electricity production(% of total) in High income: OECD per year?
Offer a very short reply. 4.16. What is the average Electricity production(% of total) of Brazil per year?
Keep it short and to the point. 4.63. What is the average Electricity production(% of total) of Switzerland per year?
Your response must be concise. 1.96. What is the average Electricity production(% of total) in Tunisia per year?
Keep it short and to the point. 0.46. In the year 2004, what is the difference between the Electricity production(% of total) of High income: OECD and Electricity production(% of total) of Brazil?
Your answer should be very brief. -0.65. In the year 2004, what is the difference between the Electricity production(% of total) in High income: OECD and Electricity production(% of total) in Switzerland?
Provide a short and direct response. 1.01. In the year 2004, what is the difference between the Electricity production(% of total) in High income: OECD and Electricity production(% of total) in Tunisia?
Provide a short and direct response. 2.21. In the year 2004, what is the difference between the Electricity production(% of total) in Brazil and Electricity production(% of total) in Switzerland?
Provide a short and direct response. 1.67. In the year 2004, what is the difference between the Electricity production(% of total) in Brazil and Electricity production(% of total) in Tunisia?
Give a very brief answer. 2.87. In the year 2004, what is the difference between the Electricity production(% of total) in Switzerland and Electricity production(% of total) in Tunisia?
Your answer should be compact. 1.2. In the year 2005, what is the difference between the Electricity production(% of total) in High income: OECD and Electricity production(% of total) in Brazil?
Provide a short and direct response. -0.5. In the year 2005, what is the difference between the Electricity production(% of total) of High income: OECD and Electricity production(% of total) of Switzerland?
Give a very brief answer. 1.07. In the year 2005, what is the difference between the Electricity production(% of total) of High income: OECD and Electricity production(% of total) of Tunisia?
Offer a very short reply. 2.56. In the year 2005, what is the difference between the Electricity production(% of total) in Brazil and Electricity production(% of total) in Switzerland?
Provide a short and direct response. 1.57. In the year 2005, what is the difference between the Electricity production(% of total) of Brazil and Electricity production(% of total) of Tunisia?
Your answer should be very brief. 3.06. In the year 2005, what is the difference between the Electricity production(% of total) in Switzerland and Electricity production(% of total) in Tunisia?
Offer a very short reply. 1.49. In the year 2006, what is the difference between the Electricity production(% of total) in High income: OECD and Electricity production(% of total) in Brazil?
Make the answer very short. -0.34. In the year 2006, what is the difference between the Electricity production(% of total) in High income: OECD and Electricity production(% of total) in Switzerland?
Offer a terse response. 1.32. In the year 2006, what is the difference between the Electricity production(% of total) of High income: OECD and Electricity production(% of total) of Tunisia?
Provide a short and direct response. 2.93. In the year 2006, what is the difference between the Electricity production(% of total) of Brazil and Electricity production(% of total) of Switzerland?
Provide a short and direct response. 1.67. In the year 2006, what is the difference between the Electricity production(% of total) in Brazil and Electricity production(% of total) in Tunisia?
Your answer should be compact. 3.28. In the year 2006, what is the difference between the Electricity production(% of total) of Switzerland and Electricity production(% of total) of Tunisia?
Give a very brief answer. 1.61. In the year 2007, what is the difference between the Electricity production(% of total) of High income: OECD and Electricity production(% of total) of Brazil?
Give a very brief answer. -0.57. In the year 2007, what is the difference between the Electricity production(% of total) of High income: OECD and Electricity production(% of total) of Switzerland?
Offer a very short reply. 1.77. In the year 2007, what is the difference between the Electricity production(% of total) in High income: OECD and Electricity production(% of total) in Tunisia?
Ensure brevity in your answer.  3.31. In the year 2007, what is the difference between the Electricity production(% of total) in Brazil and Electricity production(% of total) in Switzerland?
Ensure brevity in your answer.  2.35. In the year 2007, what is the difference between the Electricity production(% of total) of Brazil and Electricity production(% of total) of Tunisia?
Your response must be concise. 3.88. In the year 2007, what is the difference between the Electricity production(% of total) in Switzerland and Electricity production(% of total) in Tunisia?
Keep it short and to the point. 1.53. In the year 2008, what is the difference between the Electricity production(% of total) of High income: OECD and Electricity production(% of total) of Brazil?
Provide a short and direct response. -0.33. In the year 2008, what is the difference between the Electricity production(% of total) in High income: OECD and Electricity production(% of total) in Switzerland?
Keep it short and to the point. 2.21. In the year 2008, what is the difference between the Electricity production(% of total) of High income: OECD and Electricity production(% of total) of Tunisia?
Your response must be concise. 3.86. In the year 2008, what is the difference between the Electricity production(% of total) in Brazil and Electricity production(% of total) in Switzerland?
Your response must be concise. 2.54. In the year 2008, what is the difference between the Electricity production(% of total) in Brazil and Electricity production(% of total) in Tunisia?
Offer a terse response. 4.19. In the year 2008, what is the difference between the Electricity production(% of total) of Switzerland and Electricity production(% of total) of Tunisia?
Offer a terse response. 1.65. In the year 2009, what is the difference between the Electricity production(% of total) of High income: OECD and Electricity production(% of total) of Brazil?
Provide a short and direct response. -0.27. In the year 2009, what is the difference between the Electricity production(% of total) of High income: OECD and Electricity production(% of total) of Switzerland?
Your response must be concise. 2.88. In the year 2009, what is the difference between the Electricity production(% of total) of High income: OECD and Electricity production(% of total) of Tunisia?
Keep it short and to the point. 4.21. In the year 2009, what is the difference between the Electricity production(% of total) of Brazil and Electricity production(% of total) of Switzerland?
Offer a very short reply. 3.16. In the year 2009, what is the difference between the Electricity production(% of total) of Brazil and Electricity production(% of total) of Tunisia?
Your response must be concise. 4.48. In the year 2009, what is the difference between the Electricity production(% of total) in Switzerland and Electricity production(% of total) in Tunisia?
Make the answer very short. 1.32. In the year 2010, what is the difference between the Electricity production(% of total) in High income: OECD and Electricity production(% of total) in Brazil?
Ensure brevity in your answer.  -1.06. In the year 2010, what is the difference between the Electricity production(% of total) in High income: OECD and Electricity production(% of total) in Switzerland?
Provide a succinct answer. 3.36. In the year 2010, what is the difference between the Electricity production(% of total) in High income: OECD and Electricity production(% of total) in Tunisia?
Your answer should be very brief. 4.64. In the year 2010, what is the difference between the Electricity production(% of total) in Brazil and Electricity production(% of total) in Switzerland?
Offer a very short reply. 4.41. In the year 2010, what is the difference between the Electricity production(% of total) of Brazil and Electricity production(% of total) of Tunisia?
Your response must be concise. 5.7. In the year 2010, what is the difference between the Electricity production(% of total) in Switzerland and Electricity production(% of total) in Tunisia?
Offer a terse response. 1.29. In the year 2011, what is the difference between the Electricity production(% of total) in High income: OECD and Electricity production(% of total) in Brazil?
Keep it short and to the point. -0.08. In the year 2011, what is the difference between the Electricity production(% of total) of High income: OECD and Electricity production(% of total) of Switzerland?
Give a very brief answer. 3.93. In the year 2011, what is the difference between the Electricity production(% of total) of High income: OECD and Electricity production(% of total) of Tunisia?
Provide a short and direct response. 5.82. In the year 2011, what is the difference between the Electricity production(% of total) of Brazil and Electricity production(% of total) of Switzerland?
Offer a very short reply. 4.01. In the year 2011, what is the difference between the Electricity production(% of total) of Brazil and Electricity production(% of total) of Tunisia?
Give a very brief answer. 5.9. In the year 2011, what is the difference between the Electricity production(% of total) of Switzerland and Electricity production(% of total) of Tunisia?
Offer a terse response. 1.89. What is the ratio of the Electricity production(% of total) of High income: OECD in 2004 to that in 2005?
Your response must be concise. 0.89. What is the ratio of the Electricity production(% of total) of Brazil in 2004 to that in 2005?
Keep it short and to the point. 0.95. What is the ratio of the Electricity production(% of total) in Switzerland in 2004 to that in 2005?
Provide a short and direct response. 0.86. What is the ratio of the Electricity production(% of total) of Tunisia in 2004 to that in 2005?
Ensure brevity in your answer.  1.11. What is the ratio of the Electricity production(% of total) of High income: OECD in 2004 to that in 2006?
Provide a succinct answer. 0.8. What is the ratio of the Electricity production(% of total) in Brazil in 2004 to that in 2006?
Your answer should be compact. 0.91. What is the ratio of the Electricity production(% of total) of Switzerland in 2004 to that in 2006?
Keep it short and to the point. 0.82. What is the ratio of the Electricity production(% of total) in Tunisia in 2004 to that in 2006?
Ensure brevity in your answer.  1.27. What is the ratio of the Electricity production(% of total) of High income: OECD in 2004 to that in 2007?
Your answer should be very brief. 0.71. What is the ratio of the Electricity production(% of total) of Brazil in 2004 to that in 2007?
Make the answer very short. 0.77. What is the ratio of the Electricity production(% of total) of Switzerland in 2004 to that in 2007?
Ensure brevity in your answer.  0.85. What is the ratio of the Electricity production(% of total) of Tunisia in 2004 to that in 2007?
Your response must be concise. 1.18. What is the ratio of the Electricity production(% of total) in High income: OECD in 2004 to that in 2008?
Offer a terse response. 0.62. What is the ratio of the Electricity production(% of total) of Brazil in 2004 to that in 2008?
Provide a succinct answer. 0.73. What is the ratio of the Electricity production(% of total) of Switzerland in 2004 to that in 2008?
Your answer should be very brief. 0.82. What is the ratio of the Electricity production(% of total) of Tunisia in 2004 to that in 2008?
Keep it short and to the point. 1.36. What is the ratio of the Electricity production(% of total) in High income: OECD in 2004 to that in 2009?
Provide a succinct answer. 0.53. What is the ratio of the Electricity production(% of total) in Brazil in 2004 to that in 2009?
Your answer should be compact. 0.63. What is the ratio of the Electricity production(% of total) of Switzerland in 2004 to that in 2009?
Your response must be concise. 0.8. What is the ratio of the Electricity production(% of total) of Tunisia in 2004 to that in 2009?
Offer a very short reply. 0.58. What is the ratio of the Electricity production(% of total) in High income: OECD in 2004 to that in 2010?
Your answer should be compact. 0.47. What is the ratio of the Electricity production(% of total) of Brazil in 2004 to that in 2010?
Ensure brevity in your answer.  0.5. What is the ratio of the Electricity production(% of total) of Switzerland in 2004 to that in 2010?
Give a very brief answer. 0.74. What is the ratio of the Electricity production(% of total) of Tunisia in 2004 to that in 2010?
Provide a succinct answer. 0.44. What is the ratio of the Electricity production(% of total) in High income: OECD in 2004 to that in 2011?
Your answer should be compact. 0.4. What is the ratio of the Electricity production(% of total) in Brazil in 2004 to that in 2011?
Make the answer very short. 0.49. What is the ratio of the Electricity production(% of total) in Switzerland in 2004 to that in 2011?
Your response must be concise. 0.61. What is the ratio of the Electricity production(% of total) of Tunisia in 2004 to that in 2011?
Your answer should be very brief. 0.55. What is the ratio of the Electricity production(% of total) in High income: OECD in 2005 to that in 2006?
Make the answer very short. 0.9. What is the ratio of the Electricity production(% of total) of Brazil in 2005 to that in 2006?
Your answer should be very brief. 0.95. What is the ratio of the Electricity production(% of total) in Switzerland in 2005 to that in 2006?
Your response must be concise. 0.96. What is the ratio of the Electricity production(% of total) of Tunisia in 2005 to that in 2006?
Ensure brevity in your answer.  1.14. What is the ratio of the Electricity production(% of total) in High income: OECD in 2005 to that in 2007?
Your answer should be compact. 0.8. What is the ratio of the Electricity production(% of total) in Brazil in 2005 to that in 2007?
Give a very brief answer. 0.81. What is the ratio of the Electricity production(% of total) in Switzerland in 2005 to that in 2007?
Make the answer very short. 0.99. What is the ratio of the Electricity production(% of total) in Tunisia in 2005 to that in 2007?
Ensure brevity in your answer.  1.06. What is the ratio of the Electricity production(% of total) of High income: OECD in 2005 to that in 2008?
Give a very brief answer. 0.7. What is the ratio of the Electricity production(% of total) of Brazil in 2005 to that in 2008?
Provide a succinct answer. 0.76. What is the ratio of the Electricity production(% of total) in Switzerland in 2005 to that in 2008?
Your answer should be very brief. 0.95. What is the ratio of the Electricity production(% of total) of Tunisia in 2005 to that in 2008?
Offer a very short reply. 1.22. What is the ratio of the Electricity production(% of total) of High income: OECD in 2005 to that in 2009?
Provide a succinct answer. 0.6. What is the ratio of the Electricity production(% of total) of Brazil in 2005 to that in 2009?
Ensure brevity in your answer.  0.66. What is the ratio of the Electricity production(% of total) in Switzerland in 2005 to that in 2009?
Keep it short and to the point. 0.93. What is the ratio of the Electricity production(% of total) in Tunisia in 2005 to that in 2009?
Your answer should be compact. 0.52. What is the ratio of the Electricity production(% of total) in High income: OECD in 2005 to that in 2010?
Offer a very short reply. 0.53. What is the ratio of the Electricity production(% of total) in Brazil in 2005 to that in 2010?
Make the answer very short. 0.52. What is the ratio of the Electricity production(% of total) in Switzerland in 2005 to that in 2010?
Keep it short and to the point. 0.86. What is the ratio of the Electricity production(% of total) in Tunisia in 2005 to that in 2010?
Provide a short and direct response. 0.4. What is the ratio of the Electricity production(% of total) of High income: OECD in 2005 to that in 2011?
Your response must be concise. 0.45. What is the ratio of the Electricity production(% of total) in Brazil in 2005 to that in 2011?
Offer a very short reply. 0.52. What is the ratio of the Electricity production(% of total) in Switzerland in 2005 to that in 2011?
Make the answer very short. 0.71. What is the ratio of the Electricity production(% of total) of Tunisia in 2005 to that in 2011?
Your answer should be compact. 0.49. What is the ratio of the Electricity production(% of total) of High income: OECD in 2006 to that in 2007?
Make the answer very short. 0.89. What is the ratio of the Electricity production(% of total) of Brazil in 2006 to that in 2007?
Your answer should be compact. 0.85. What is the ratio of the Electricity production(% of total) of Switzerland in 2006 to that in 2007?
Your answer should be compact. 1.03. What is the ratio of the Electricity production(% of total) in Tunisia in 2006 to that in 2007?
Ensure brevity in your answer.  0.93. What is the ratio of the Electricity production(% of total) of High income: OECD in 2006 to that in 2008?
Your response must be concise. 0.78. What is the ratio of the Electricity production(% of total) in Brazil in 2006 to that in 2008?
Your answer should be very brief. 0.8. What is the ratio of the Electricity production(% of total) in Tunisia in 2006 to that in 2008?
Give a very brief answer. 1.07. What is the ratio of the Electricity production(% of total) in High income: OECD in 2006 to that in 2009?
Offer a terse response. 0.67. What is the ratio of the Electricity production(% of total) of Brazil in 2006 to that in 2009?
Your answer should be very brief. 0.7. What is the ratio of the Electricity production(% of total) in Switzerland in 2006 to that in 2009?
Your response must be concise. 0.97. What is the ratio of the Electricity production(% of total) in Tunisia in 2006 to that in 2009?
Your response must be concise. 0.46. What is the ratio of the Electricity production(% of total) of High income: OECD in 2006 to that in 2010?
Provide a succinct answer. 0.59. What is the ratio of the Electricity production(% of total) in Brazil in 2006 to that in 2010?
Your answer should be very brief. 0.55. What is the ratio of the Electricity production(% of total) of Switzerland in 2006 to that in 2010?
Make the answer very short. 0.9. What is the ratio of the Electricity production(% of total) of Tunisia in 2006 to that in 2010?
Your answer should be very brief. 0.35. What is the ratio of the Electricity production(% of total) in High income: OECD in 2006 to that in 2011?
Your answer should be very brief. 0.5. What is the ratio of the Electricity production(% of total) in Brazil in 2006 to that in 2011?
Provide a short and direct response. 0.54. What is the ratio of the Electricity production(% of total) of Switzerland in 2006 to that in 2011?
Keep it short and to the point. 0.74. What is the ratio of the Electricity production(% of total) of Tunisia in 2006 to that in 2011?
Provide a succinct answer. 0.43. What is the ratio of the Electricity production(% of total) in High income: OECD in 2007 to that in 2008?
Provide a succinct answer. 0.88. What is the ratio of the Electricity production(% of total) in Brazil in 2007 to that in 2008?
Offer a very short reply. 0.94. What is the ratio of the Electricity production(% of total) in Switzerland in 2007 to that in 2008?
Give a very brief answer. 0.96. What is the ratio of the Electricity production(% of total) of Tunisia in 2007 to that in 2008?
Make the answer very short. 1.15. What is the ratio of the Electricity production(% of total) of High income: OECD in 2007 to that in 2009?
Your answer should be compact. 0.75. What is the ratio of the Electricity production(% of total) of Brazil in 2007 to that in 2009?
Provide a short and direct response. 0.82. What is the ratio of the Electricity production(% of total) of Switzerland in 2007 to that in 2009?
Keep it short and to the point. 0.94. What is the ratio of the Electricity production(% of total) in Tunisia in 2007 to that in 2009?
Your response must be concise. 0.49. What is the ratio of the Electricity production(% of total) of High income: OECD in 2007 to that in 2010?
Give a very brief answer. 0.66. What is the ratio of the Electricity production(% of total) of Brazil in 2007 to that in 2010?
Give a very brief answer. 0.64. What is the ratio of the Electricity production(% of total) in Switzerland in 2007 to that in 2010?
Give a very brief answer. 0.87. What is the ratio of the Electricity production(% of total) of Tunisia in 2007 to that in 2010?
Offer a terse response. 0.38. What is the ratio of the Electricity production(% of total) of High income: OECD in 2007 to that in 2011?
Provide a succinct answer. 0.56. What is the ratio of the Electricity production(% of total) in Brazil in 2007 to that in 2011?
Your response must be concise. 0.64. What is the ratio of the Electricity production(% of total) of Switzerland in 2007 to that in 2011?
Make the answer very short. 0.72. What is the ratio of the Electricity production(% of total) in Tunisia in 2007 to that in 2011?
Provide a short and direct response. 0.47. What is the ratio of the Electricity production(% of total) of High income: OECD in 2008 to that in 2009?
Your response must be concise. 0.85. What is the ratio of the Electricity production(% of total) in Brazil in 2008 to that in 2009?
Provide a short and direct response. 0.87. What is the ratio of the Electricity production(% of total) in Switzerland in 2008 to that in 2009?
Provide a short and direct response. 0.98. What is the ratio of the Electricity production(% of total) of Tunisia in 2008 to that in 2009?
Ensure brevity in your answer.  0.43. What is the ratio of the Electricity production(% of total) of High income: OECD in 2008 to that in 2010?
Keep it short and to the point. 0.75. What is the ratio of the Electricity production(% of total) in Brazil in 2008 to that in 2010?
Offer a very short reply. 0.68. What is the ratio of the Electricity production(% of total) in Switzerland in 2008 to that in 2010?
Provide a short and direct response. 0.91. What is the ratio of the Electricity production(% of total) of Tunisia in 2008 to that in 2010?
Give a very brief answer. 0.33. What is the ratio of the Electricity production(% of total) in High income: OECD in 2008 to that in 2011?
Keep it short and to the point. 0.64. What is the ratio of the Electricity production(% of total) in Brazil in 2008 to that in 2011?
Your answer should be compact. 0.68. What is the ratio of the Electricity production(% of total) in Switzerland in 2008 to that in 2011?
Give a very brief answer. 0.75. What is the ratio of the Electricity production(% of total) in Tunisia in 2008 to that in 2011?
Make the answer very short. 0.4. What is the ratio of the Electricity production(% of total) of High income: OECD in 2009 to that in 2010?
Keep it short and to the point. 0.88. What is the ratio of the Electricity production(% of total) in Brazil in 2009 to that in 2010?
Your answer should be very brief. 0.78. What is the ratio of the Electricity production(% of total) in Switzerland in 2009 to that in 2010?
Your answer should be compact. 0.92. What is the ratio of the Electricity production(% of total) of Tunisia in 2009 to that in 2010?
Offer a very short reply. 0.76. What is the ratio of the Electricity production(% of total) in High income: OECD in 2009 to that in 2011?
Give a very brief answer. 0.75. What is the ratio of the Electricity production(% of total) of Brazil in 2009 to that in 2011?
Offer a terse response. 0.78. What is the ratio of the Electricity production(% of total) of Switzerland in 2009 to that in 2011?
Your answer should be very brief. 0.77. What is the ratio of the Electricity production(% of total) in Tunisia in 2009 to that in 2011?
Provide a succinct answer. 0.95. What is the ratio of the Electricity production(% of total) in High income: OECD in 2010 to that in 2011?
Make the answer very short. 0.84. What is the ratio of the Electricity production(% of total) in Switzerland in 2010 to that in 2011?
Keep it short and to the point. 0.83. What is the ratio of the Electricity production(% of total) of Tunisia in 2010 to that in 2011?
Your answer should be compact. 1.24. What is the difference between the highest and the second highest Electricity production(% of total) in High income: OECD?
Offer a very short reply. 1.01. What is the difference between the highest and the second highest Electricity production(% of total) of Brazil?
Provide a succinct answer. 0.04. What is the difference between the highest and the second highest Electricity production(% of total) of Switzerland?
Provide a succinct answer. 0.44. What is the difference between the highest and the second highest Electricity production(% of total) in Tunisia?
Provide a short and direct response. 0.16. What is the difference between the highest and the lowest Electricity production(% of total) in High income: OECD?
Offer a terse response. 3.91. What is the difference between the highest and the lowest Electricity production(% of total) in Brazil?
Provide a succinct answer. 3.33. What is the difference between the highest and the lowest Electricity production(% of total) of Switzerland?
Provide a short and direct response. 0.99. What is the difference between the highest and the lowest Electricity production(% of total) in Tunisia?
Your answer should be very brief. 0.56. 